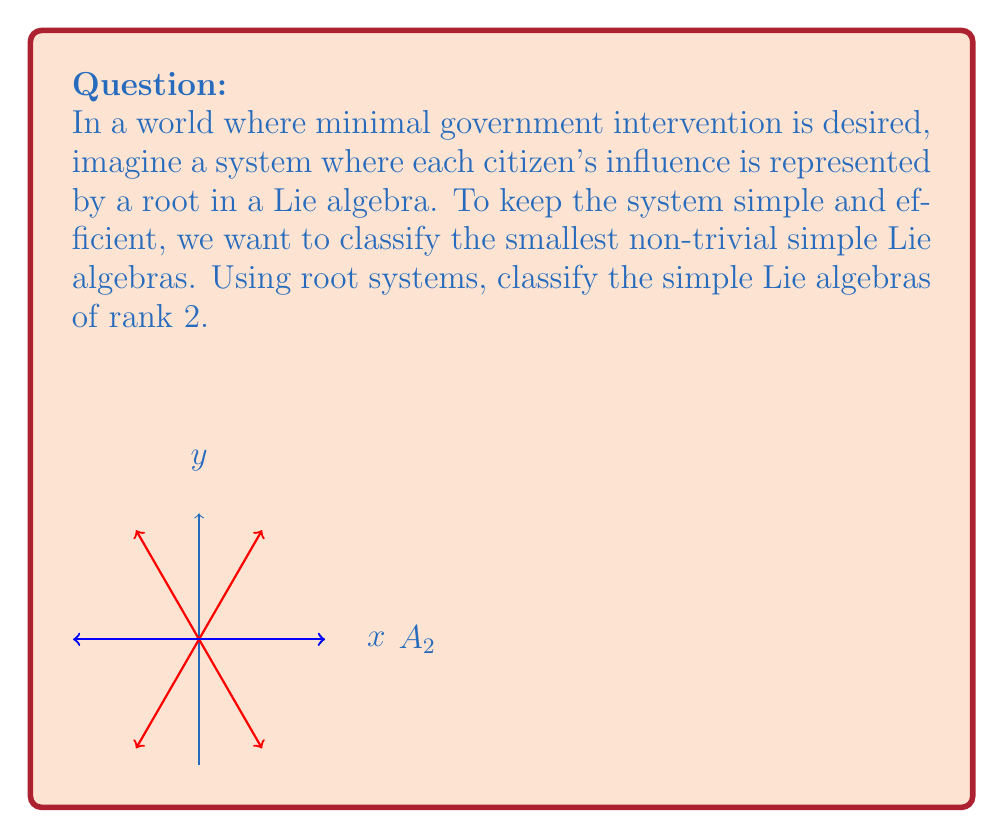Could you help me with this problem? To classify the simple Lie algebras of rank 2 using root systems, we follow these steps:

1) Recall that the rank of a Lie algebra is the dimension of its Cartan subalgebra, which corresponds to the dimension of the root space.

2) For rank 2, we are looking for root systems in a 2-dimensional space.

3) The possible simple Lie algebras of rank 2 are:

   a) $A_2$ (corresponding to $\mathfrak{sl}(3,\mathbb{C})$)
   b) $B_2 \cong C_2$ (corresponding to $\mathfrak{so}(5,\mathbb{C}) \cong \mathfrak{sp}(4,\mathbb{C})$)
   c) $G_2$ (the exceptional Lie algebra)

4) Let's examine their root systems:

   a) $A_2$: 
      - 6 roots forming a regular hexagon
      - Roots: $\pm(\alpha_1), \pm(\alpha_2), \pm(\alpha_1+\alpha_2)$
      - Angle between simple roots: 120°

   b) $B_2 \cong C_2$:
      - 8 roots forming a square with doubled edges
      - Roots: $\pm(\alpha_1), \pm(\alpha_2), \pm(\alpha_1+\alpha_2), \pm(\alpha_1+2\alpha_2)$
      - Angle between simple roots: 135°

   c) $G_2$:
      - 12 roots forming a regular hexagon with doubled edges
      - Roots: $\pm(\alpha_1), \pm(\alpha_2), \pm(\alpha_1+\alpha_2), \pm(2\alpha_1+\alpha_2), \pm(3\alpha_1+\alpha_2), \pm(3\alpha_1+2\alpha_2)$
      - Angle between simple roots: 150°

5) These three root systems completely classify the simple Lie algebras of rank 2.

In the context of minimal government intervention, these systems represent the most efficient ways to organize influence with just two fundamental types of actors (corresponding to the two simple roots).
Answer: $A_2$, $B_2 \cong C_2$, and $G_2$ 